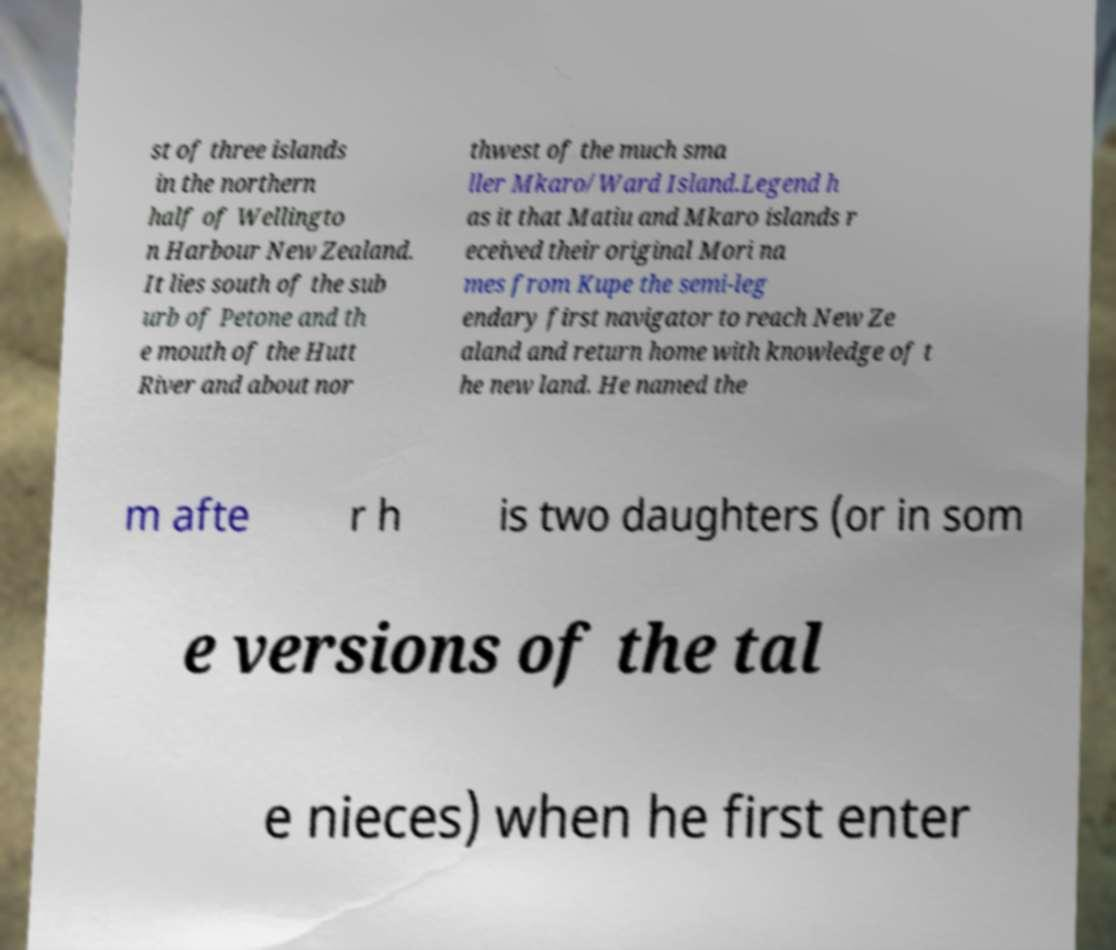Could you extract and type out the text from this image? st of three islands in the northern half of Wellingto n Harbour New Zealand. It lies south of the sub urb of Petone and th e mouth of the Hutt River and about nor thwest of the much sma ller Mkaro/Ward Island.Legend h as it that Matiu and Mkaro islands r eceived their original Mori na mes from Kupe the semi-leg endary first navigator to reach New Ze aland and return home with knowledge of t he new land. He named the m afte r h is two daughters (or in som e versions of the tal e nieces) when he first enter 